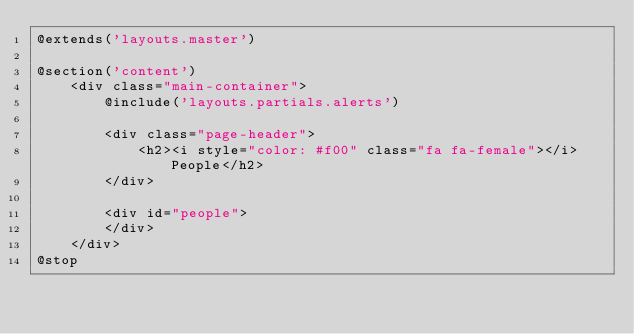<code> <loc_0><loc_0><loc_500><loc_500><_PHP_>@extends('layouts.master')

@section('content')
    <div class="main-container">
        @include('layouts.partials.alerts')

        <div class="page-header">
            <h2><i style="color: #f00" class="fa fa-female"></i>People</h2>
        </div>

        <div id="people">
        </div>
    </div>
@stop</code> 